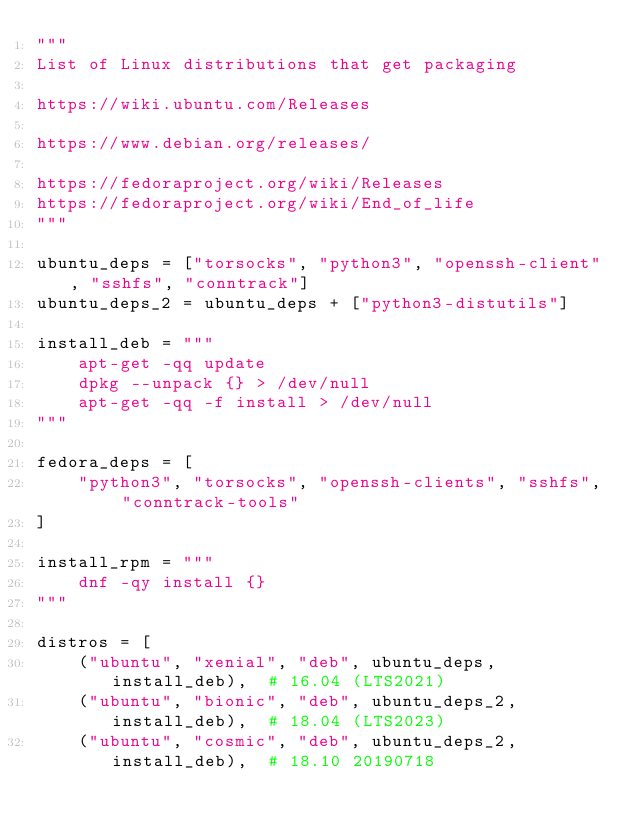<code> <loc_0><loc_0><loc_500><loc_500><_Python_>"""
List of Linux distributions that get packaging

https://wiki.ubuntu.com/Releases

https://www.debian.org/releases/

https://fedoraproject.org/wiki/Releases
https://fedoraproject.org/wiki/End_of_life
"""

ubuntu_deps = ["torsocks", "python3", "openssh-client", "sshfs", "conntrack"]
ubuntu_deps_2 = ubuntu_deps + ["python3-distutils"]

install_deb = """
    apt-get -qq update
    dpkg --unpack {} > /dev/null
    apt-get -qq -f install > /dev/null
"""

fedora_deps = [
    "python3", "torsocks", "openssh-clients", "sshfs", "conntrack-tools"
]

install_rpm = """
    dnf -qy install {}
"""

distros = [
    ("ubuntu", "xenial", "deb", ubuntu_deps, install_deb),  # 16.04 (LTS2021)
    ("ubuntu", "bionic", "deb", ubuntu_deps_2, install_deb),  # 18.04 (LTS2023)
    ("ubuntu", "cosmic", "deb", ubuntu_deps_2, install_deb),  # 18.10 20190718</code> 